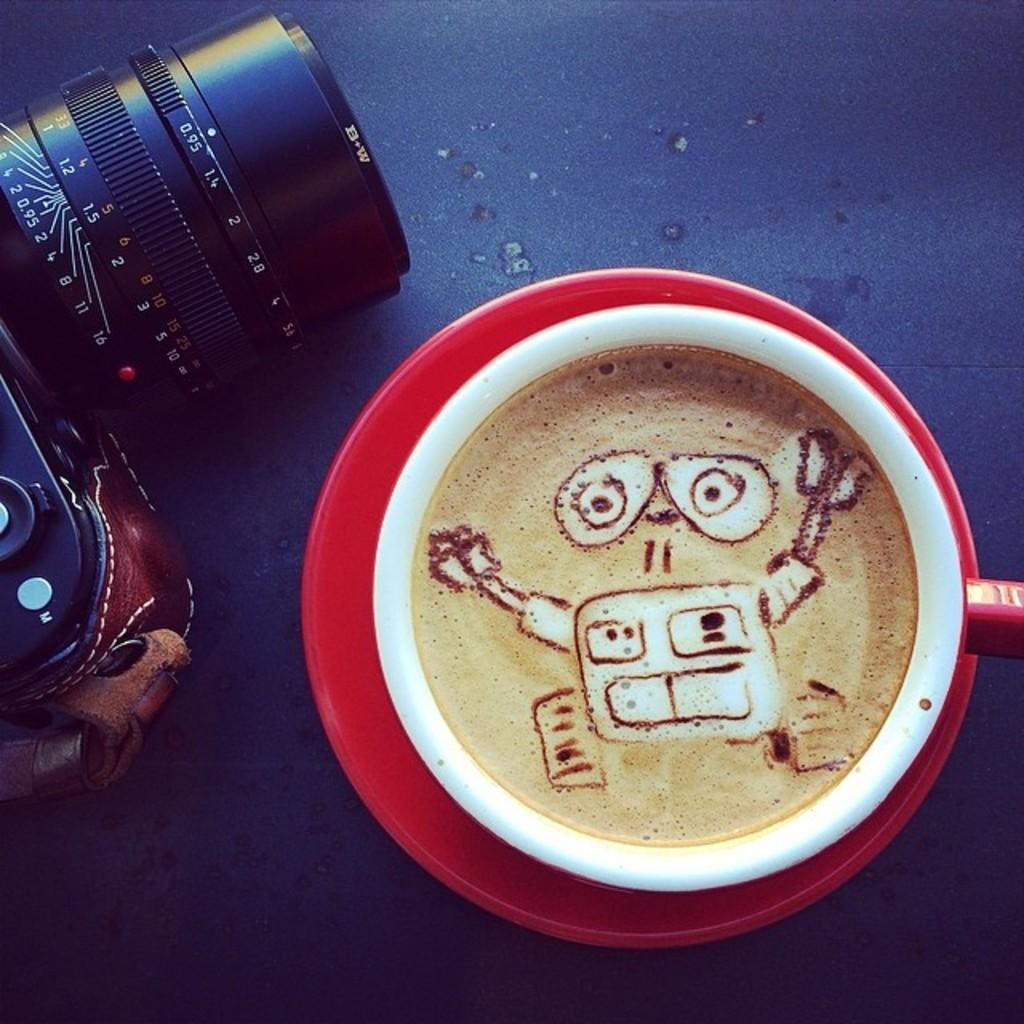What is the main object in the picture? There is a camera in the picture. What other object can be seen in the picture? There is a coffee cup in the picture. Is there anything accompanying the coffee cup? Yes, there is a saucer in the picture. What is the color of the surface on which the objects are placed? The objects are placed on a blue surface. What type of building is being constructed in the image? There is no building or construction activity present in the image; it features a camera, coffee cup, and saucer on a blue surface. 